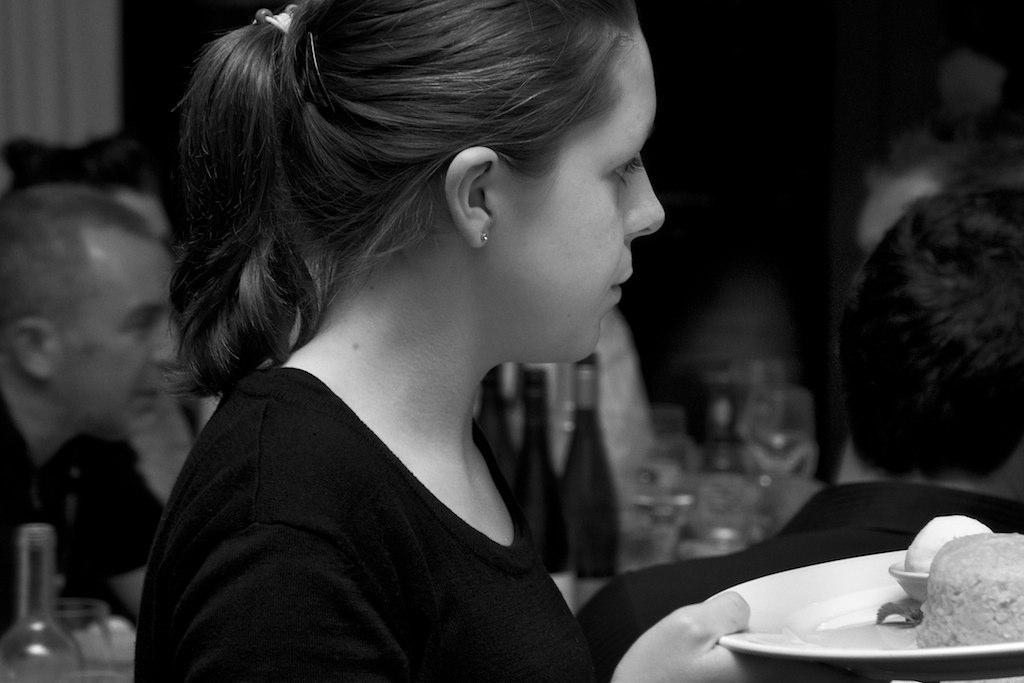Who is the main subject in the image? There is a woman in the image. What is the woman holding in the image? The woman is holding a plate of food. What can be seen in the background of the image? There are people sitting in the background. What type of containers are present in the image? Bottles and glasses are present in the image. What type of oatmeal is being served in the nest in the image? There is no oatmeal or nest present in the image. How are the people transporting themselves in the image? The image does not show any form of transportation; it only depicts people sitting in the background. 